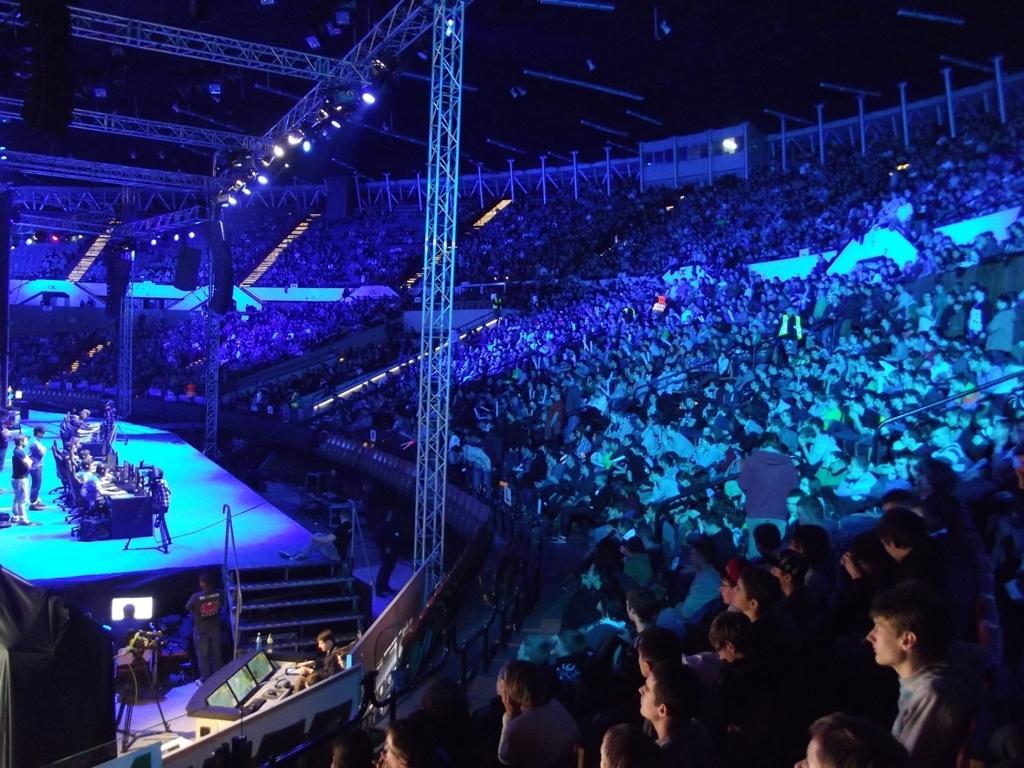Can you describe this image briefly? In this picture I can see there is a dais and they are sitting on the chairs and on the right side I can see there are audience sitting. 